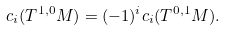Convert formula to latex. <formula><loc_0><loc_0><loc_500><loc_500>c _ { i } ( T ^ { 1 , 0 } M ) = ( - 1 ) ^ { i } c _ { i } ( T ^ { 0 , 1 } M ) .</formula> 